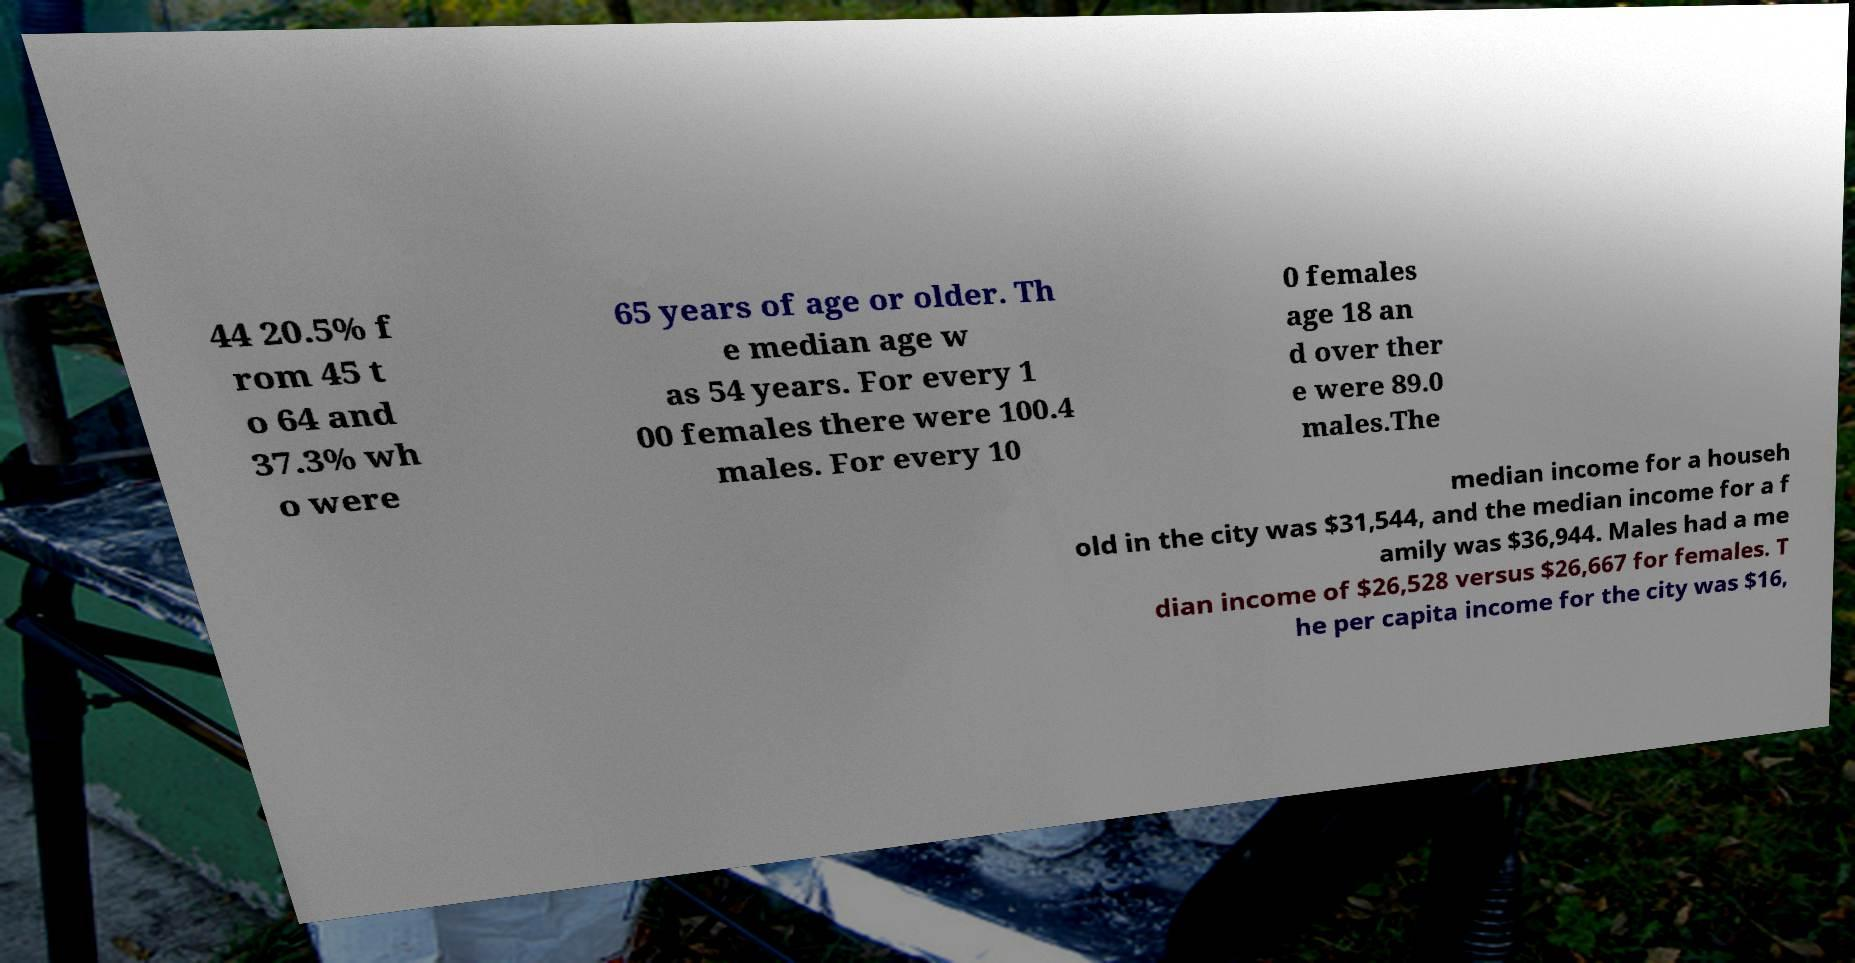Can you accurately transcribe the text from the provided image for me? 44 20.5% f rom 45 t o 64 and 37.3% wh o were 65 years of age or older. Th e median age w as 54 years. For every 1 00 females there were 100.4 males. For every 10 0 females age 18 an d over ther e were 89.0 males.The median income for a househ old in the city was $31,544, and the median income for a f amily was $36,944. Males had a me dian income of $26,528 versus $26,667 for females. T he per capita income for the city was $16, 